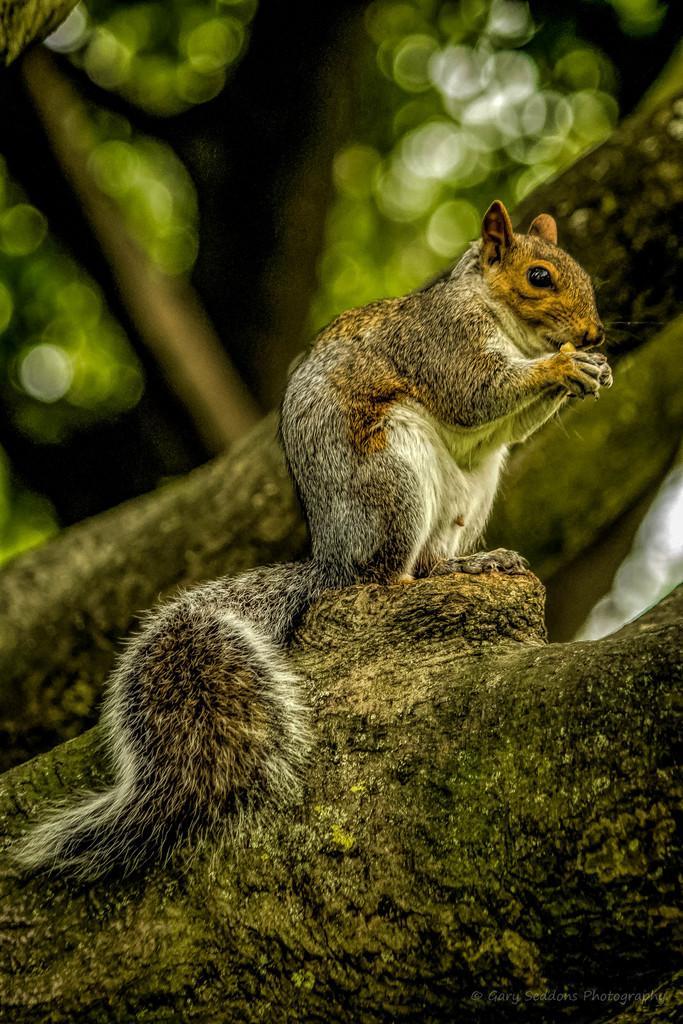Could you give a brief overview of what you see in this image? In the image we can see in front there is a squirrel standing on the tree log. 